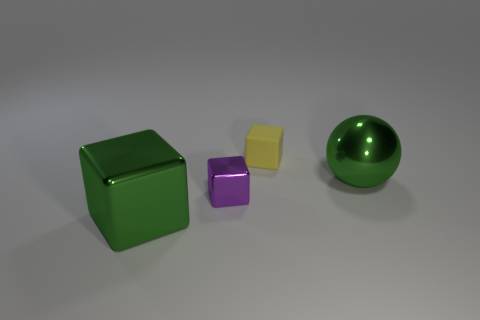Add 2 big green blocks. How many objects exist? 6 Subtract all blocks. How many objects are left? 1 Subtract 0 purple spheres. How many objects are left? 4 Subtract all small purple objects. Subtract all purple things. How many objects are left? 2 Add 3 yellow rubber cubes. How many yellow rubber cubes are left? 4 Add 3 small purple things. How many small purple things exist? 4 